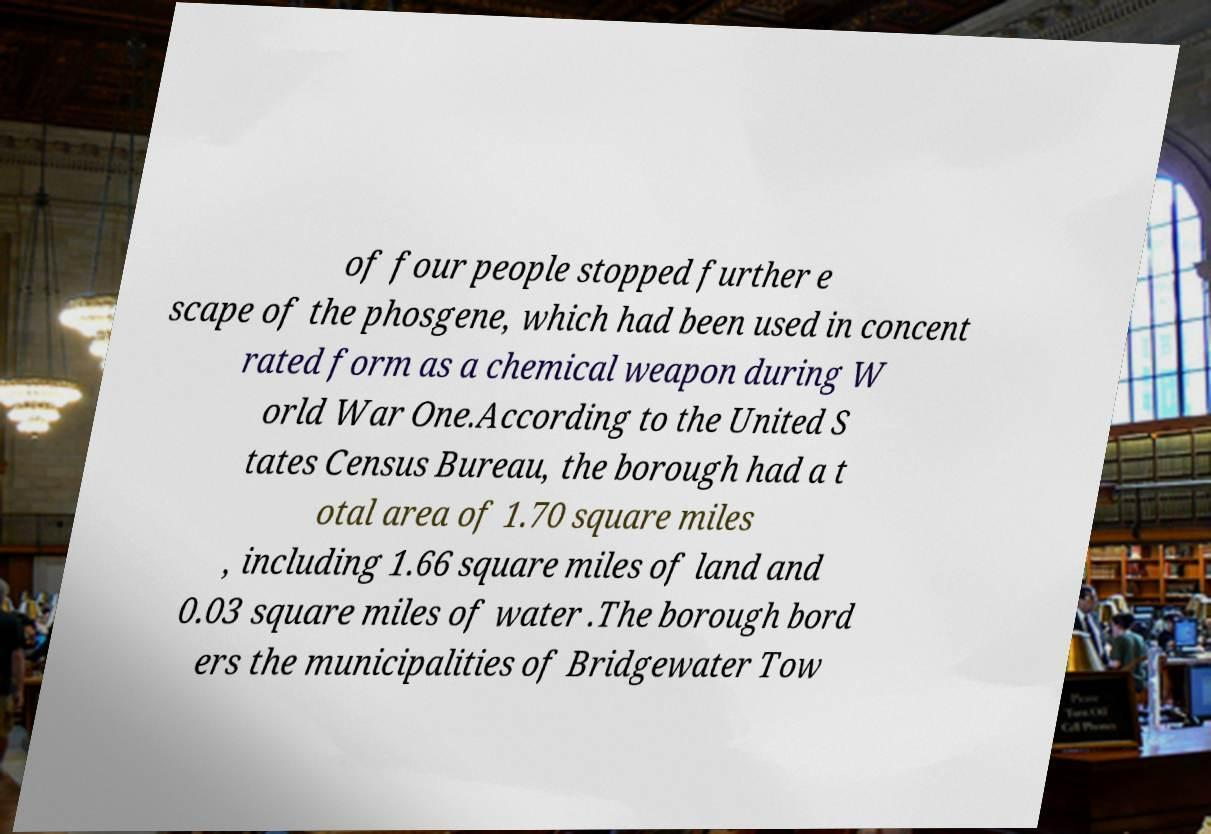Please read and relay the text visible in this image. What does it say? of four people stopped further e scape of the phosgene, which had been used in concent rated form as a chemical weapon during W orld War One.According to the United S tates Census Bureau, the borough had a t otal area of 1.70 square miles , including 1.66 square miles of land and 0.03 square miles of water .The borough bord ers the municipalities of Bridgewater Tow 